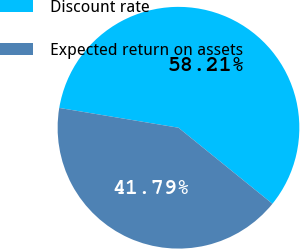<chart> <loc_0><loc_0><loc_500><loc_500><pie_chart><fcel>Discount rate<fcel>Expected return on assets<nl><fcel>58.21%<fcel>41.79%<nl></chart> 